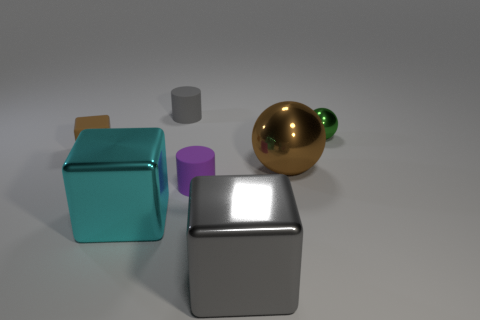Does the gray rubber thing have the same size as the cylinder that is in front of the tiny brown object?
Provide a short and direct response. Yes. How many rubber objects are either cubes or tiny purple cylinders?
Give a very brief answer. 2. How many other things are the same shape as the cyan metal object?
Keep it short and to the point. 2. There is a block that is the same color as the large ball; what is its material?
Offer a very short reply. Rubber. Do the rubber thing on the left side of the gray cylinder and the shiny block to the left of the gray metal cube have the same size?
Offer a terse response. No. There is a large object that is behind the large cyan metal block; what is its shape?
Offer a very short reply. Sphere. What is the material of the other object that is the same shape as the purple matte object?
Give a very brief answer. Rubber. Do the cylinder that is behind the green sphere and the small purple object have the same size?
Give a very brief answer. Yes. There is a cyan metallic block; what number of big cyan metallic cubes are on the right side of it?
Ensure brevity in your answer.  0. Is the number of big cyan metallic things that are in front of the gray metallic cube less than the number of big gray cubes in front of the gray rubber cylinder?
Ensure brevity in your answer.  Yes. 